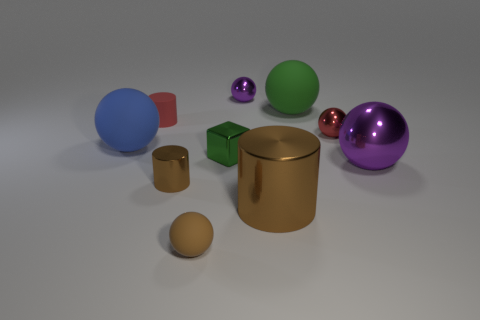How many tiny yellow matte cylinders are there?
Your answer should be compact. 0. There is a large brown metal cylinder; are there any brown metal objects to the left of it?
Keep it short and to the point. Yes. Is the red cylinder left of the brown ball made of the same material as the large thing that is in front of the large shiny ball?
Offer a very short reply. No. Are there fewer small cylinders in front of the green metallic thing than red metallic balls?
Provide a succinct answer. No. The small ball behind the red sphere is what color?
Offer a very short reply. Purple. There is a small cylinder that is in front of the big metallic thing to the right of the big green matte thing; what is it made of?
Keep it short and to the point. Metal. Is there a metal cube that has the same size as the brown ball?
Your response must be concise. Yes. What number of objects are either matte things behind the small brown metallic object or small red things that are on the left side of the small brown shiny cylinder?
Ensure brevity in your answer.  3. Do the rubber thing that is to the right of the block and the cylinder that is behind the tiny brown shiny cylinder have the same size?
Your answer should be very brief. No. Are there any tiny brown metal cylinders that are behind the red rubber thing left of the red sphere?
Provide a succinct answer. No. 